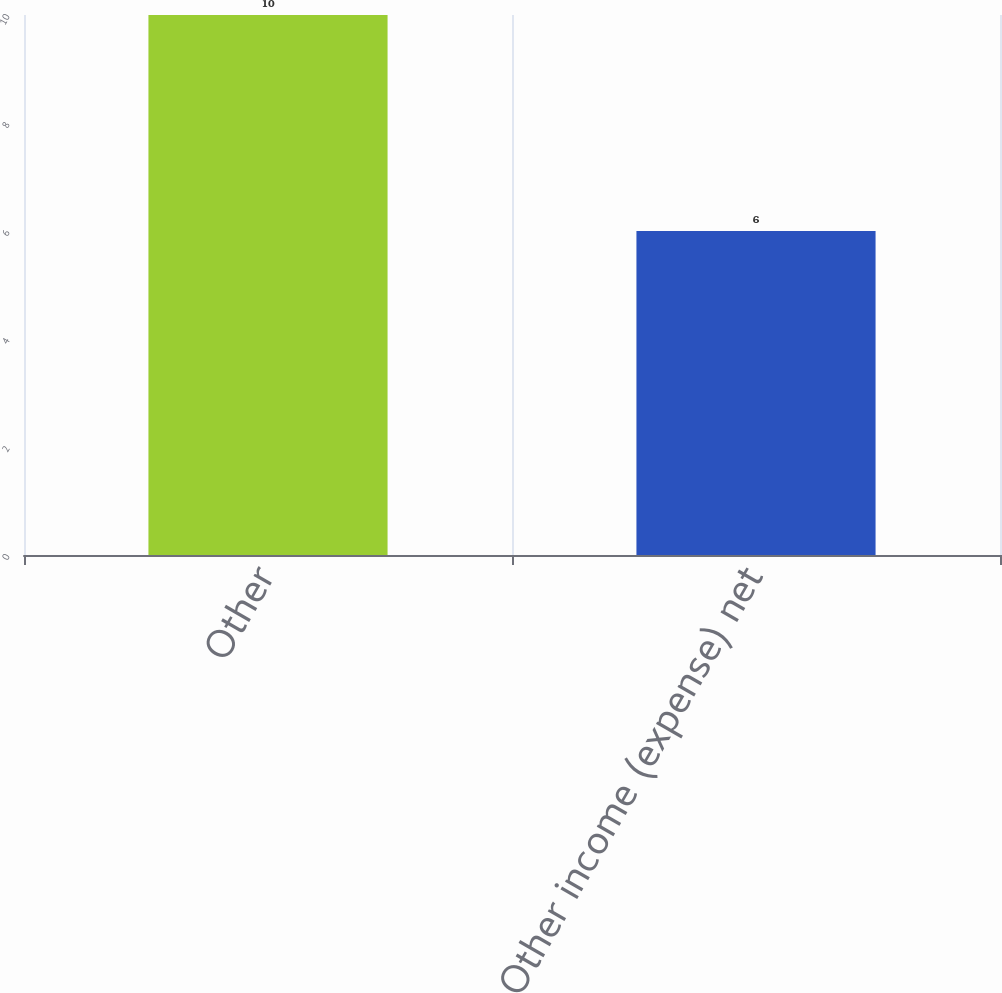<chart> <loc_0><loc_0><loc_500><loc_500><bar_chart><fcel>Other<fcel>Other income (expense) net<nl><fcel>10<fcel>6<nl></chart> 